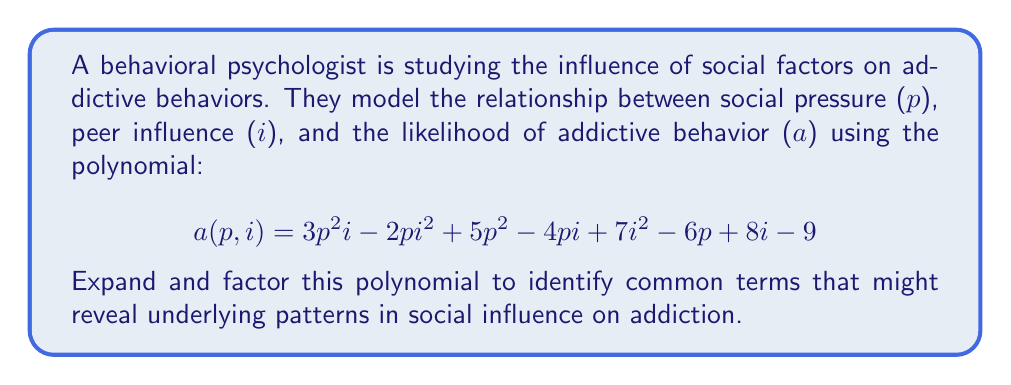Help me with this question. Let's approach this step-by-step:

1) First, we need to group terms with similar variables:

   $a(p,i) = (3p^2i - 2pi^2) + (5p^2 - 4pi) + (7i^2 + 8i) + (-6p - 9)$

2) Now, let's factor out common terms from each group:

   $a(p,i) = pi(3p - 2i) + p(5p - 4i) + i(7i + 8) + (-3)(2p + 3)$

3) We can further factor the last term:

   $a(p,i) = pi(3p - 2i) + p(5p - 4i) + i(7i + 8) - 3(2p + 3)$

4) Now, let's look for any common factors among these terms. We can see that $p$ is common to the first two terms:

   $a(p,i) = p[i(3p - 2i) + (5p - 4i)] + i(7i + 8) - 3(2p + 3)$

5) Inside the square brackets, we can factor out an $i$:

   $a(p,i) = p[i(3p - 2i) + 5p - 4i] + i(7i + 8) - 3(2p + 3)$
   $a(p,i) = p[i(3p - 2i) + (5p - 4i)] + i(7i + 8) - 3(2p + 3)$

6) This is the most factored form we can achieve without introducing complex numbers or assuming specific values for $p$ and $i$.

This factored form reveals that the influence of social pressure (p) and peer influence (i) on addictive behavior is not simply additive, but involves complex interactions between these factors.
Answer: $a(p,i) = p[i(3p - 2i) + (5p - 4i)] + i(7i + 8) - 3(2p + 3)$ 